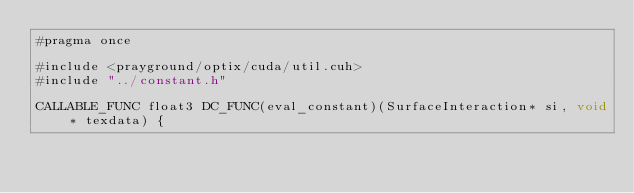Convert code to text. <code><loc_0><loc_0><loc_500><loc_500><_Cuda_>#pragma once 

#include <prayground/optix/cuda/util.cuh>
#include "../constant.h"

CALLABLE_FUNC float3 DC_FUNC(eval_constant)(SurfaceInteraction* si, void* texdata) {</code> 